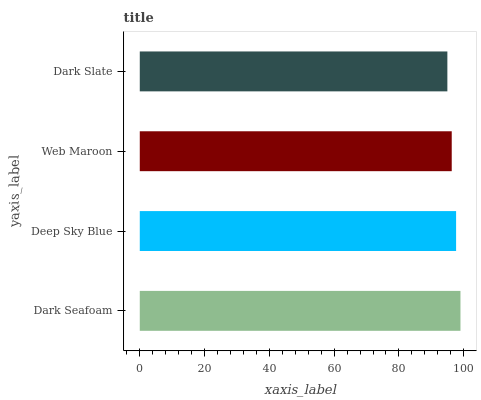Is Dark Slate the minimum?
Answer yes or no. Yes. Is Dark Seafoam the maximum?
Answer yes or no. Yes. Is Deep Sky Blue the minimum?
Answer yes or no. No. Is Deep Sky Blue the maximum?
Answer yes or no. No. Is Dark Seafoam greater than Deep Sky Blue?
Answer yes or no. Yes. Is Deep Sky Blue less than Dark Seafoam?
Answer yes or no. Yes. Is Deep Sky Blue greater than Dark Seafoam?
Answer yes or no. No. Is Dark Seafoam less than Deep Sky Blue?
Answer yes or no. No. Is Deep Sky Blue the high median?
Answer yes or no. Yes. Is Web Maroon the low median?
Answer yes or no. Yes. Is Dark Seafoam the high median?
Answer yes or no. No. Is Dark Seafoam the low median?
Answer yes or no. No. 